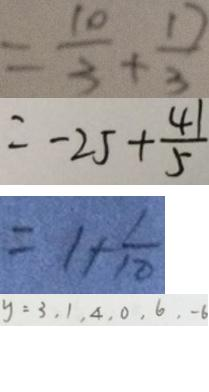<formula> <loc_0><loc_0><loc_500><loc_500>= \frac { 1 0 } { 3 } + \frac { 1 7 } { 3 } 
 = - 2 5 + \frac { 4 1 } { 5 } 
 = 1 + \frac { 1 } { 1 0 } 
 y = 3 , 1 , 4 , 0 , 6 , - 6</formula> 